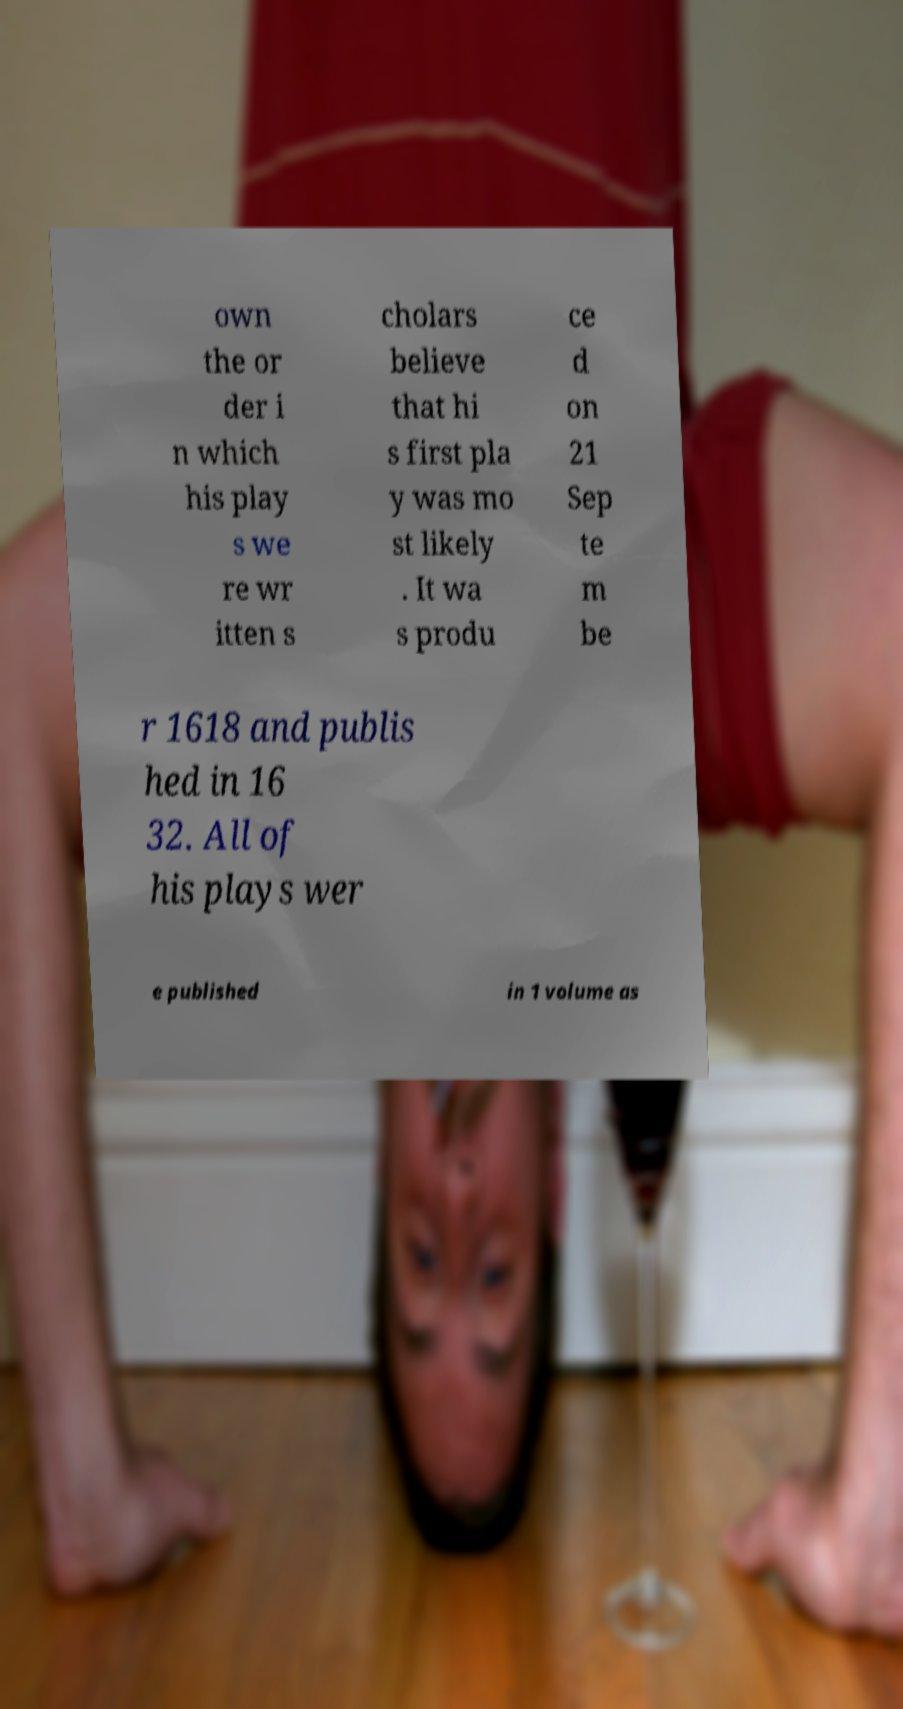Can you accurately transcribe the text from the provided image for me? own the or der i n which his play s we re wr itten s cholars believe that hi s first pla y was mo st likely . It wa s produ ce d on 21 Sep te m be r 1618 and publis hed in 16 32. All of his plays wer e published in 1 volume as 